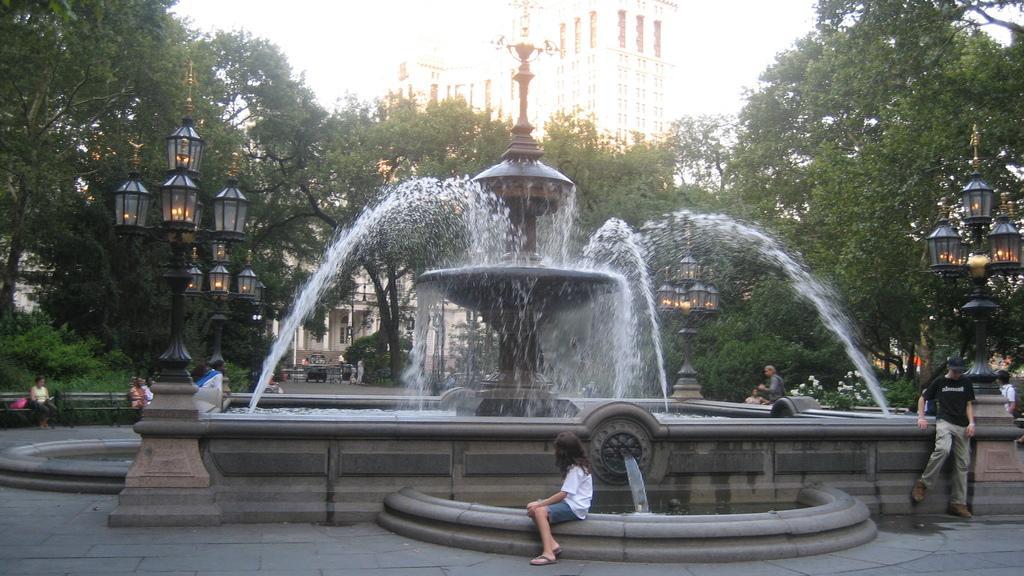Can you describe this image briefly? In the picture we can see a fountain around it we can see four poles with lamps and some people standing near the fountain and behind the fountain we can see trees and building and behind it we can see a sky. 